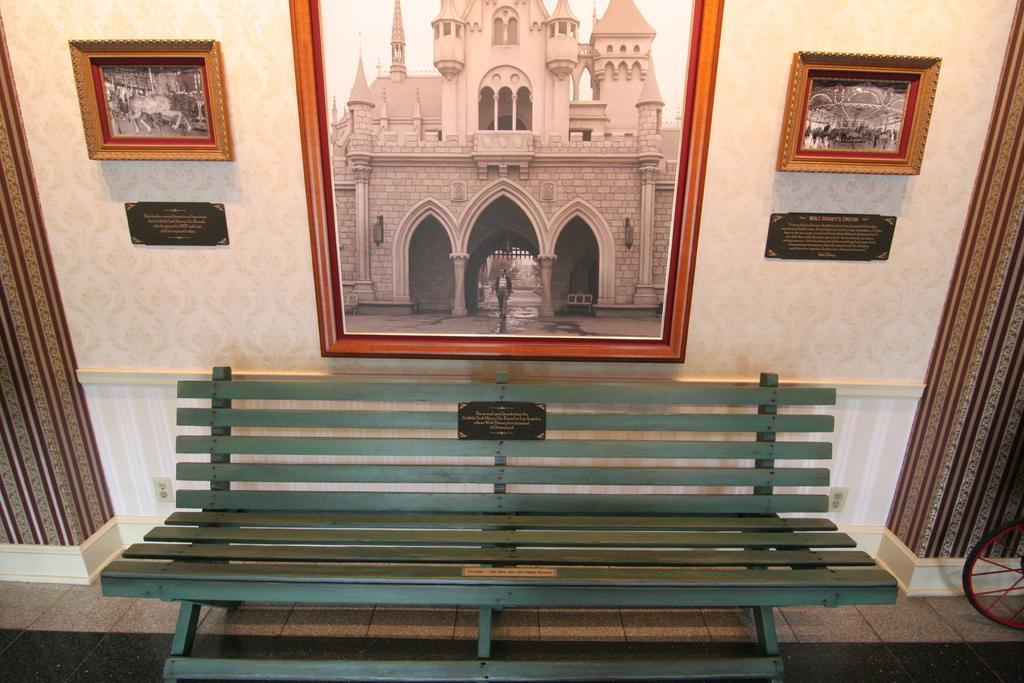Describe this image in one or two sentences. Here I can see a bench placed on the floor. At the top of the image there are few photo frames attached to the wall. On the right and left side of the image I can see the curtains. 